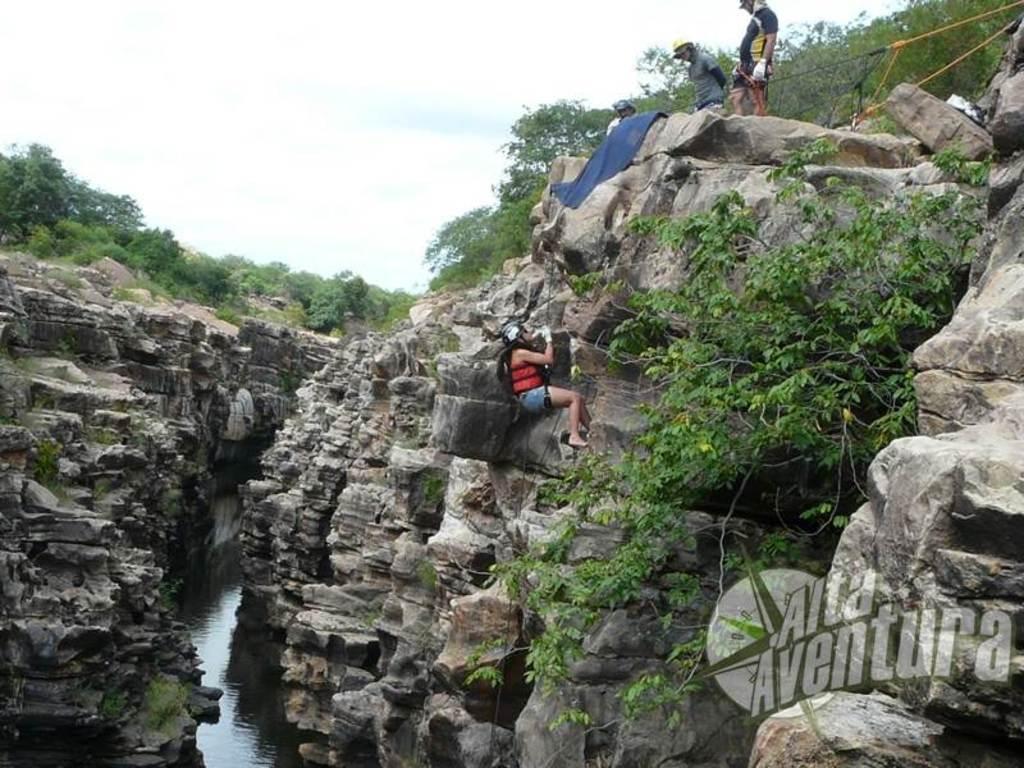Please provide a concise description of this image. In this picture there is a man who is wearing helmet, gloves, jacket, bag, short and he is holding a rope. At the top of the hill there are three persons were standing and holding the ropes. At the bottom I can see the water. In the background I can see many trees, plants and grass. At the top I can see the sky and clouds. 